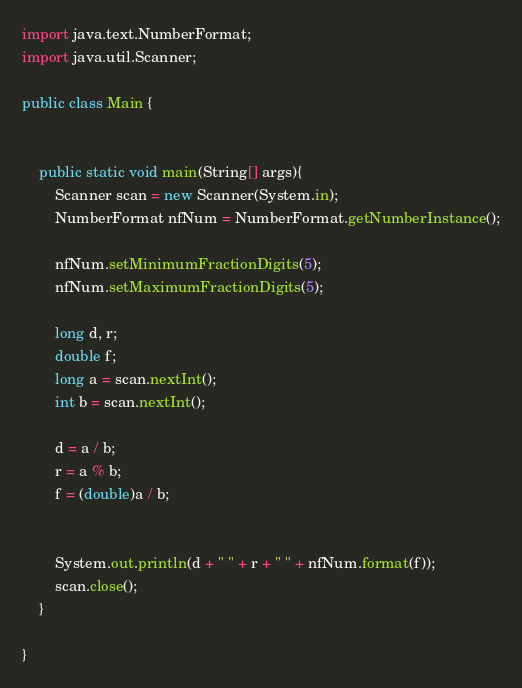Convert code to text. <code><loc_0><loc_0><loc_500><loc_500><_Java_>import java.text.NumberFormat;
import java.util.Scanner;

public class Main {


    public static void main(String[] args){
		Scanner scan = new Scanner(System.in);
		NumberFormat nfNum = NumberFormat.getNumberInstance();

		nfNum.setMinimumFractionDigits(5);
		nfNum.setMaximumFractionDigits(5);

		long d, r;
		double f;
		long a = scan.nextInt();
		int b = scan.nextInt();

		d = a / b;
		r = a % b;
		f = (double)a / b;


		System.out.println(d + " " + r + " " + nfNum.format(f));
        scan.close();
    }

}</code> 